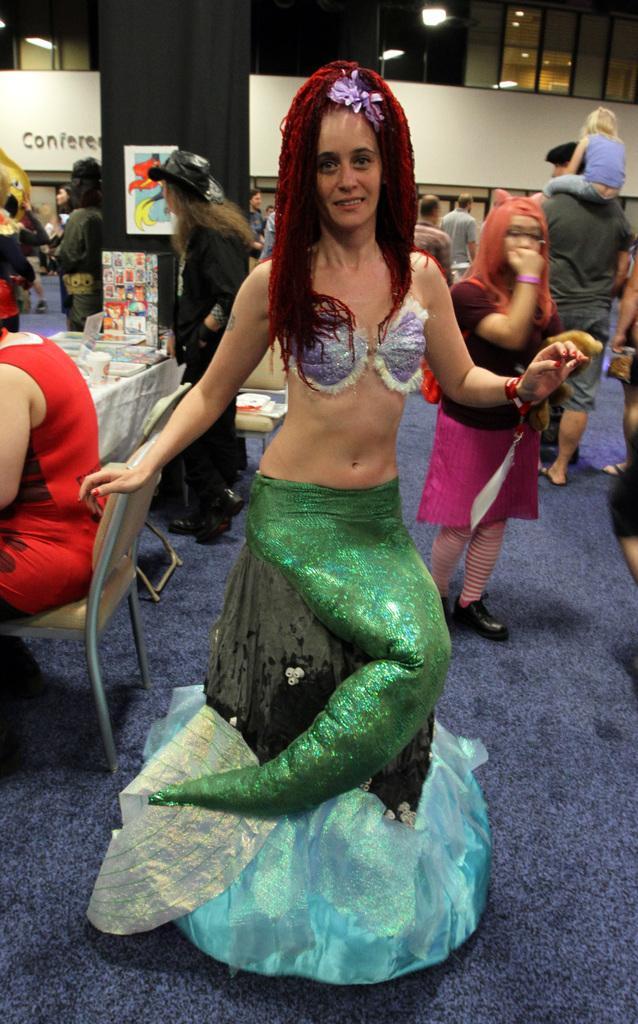In one or two sentences, can you explain what this image depicts? In this image in the front there is a woman standing and wearing a costume and smiling. In the background there are persons standing and sitting. On the left side there is a table, on the table there are objects and there is a pillar which is covered with black colour sheet and there is a board and on the board there is some text written. On the floor there is a mat which is blue in colour. 